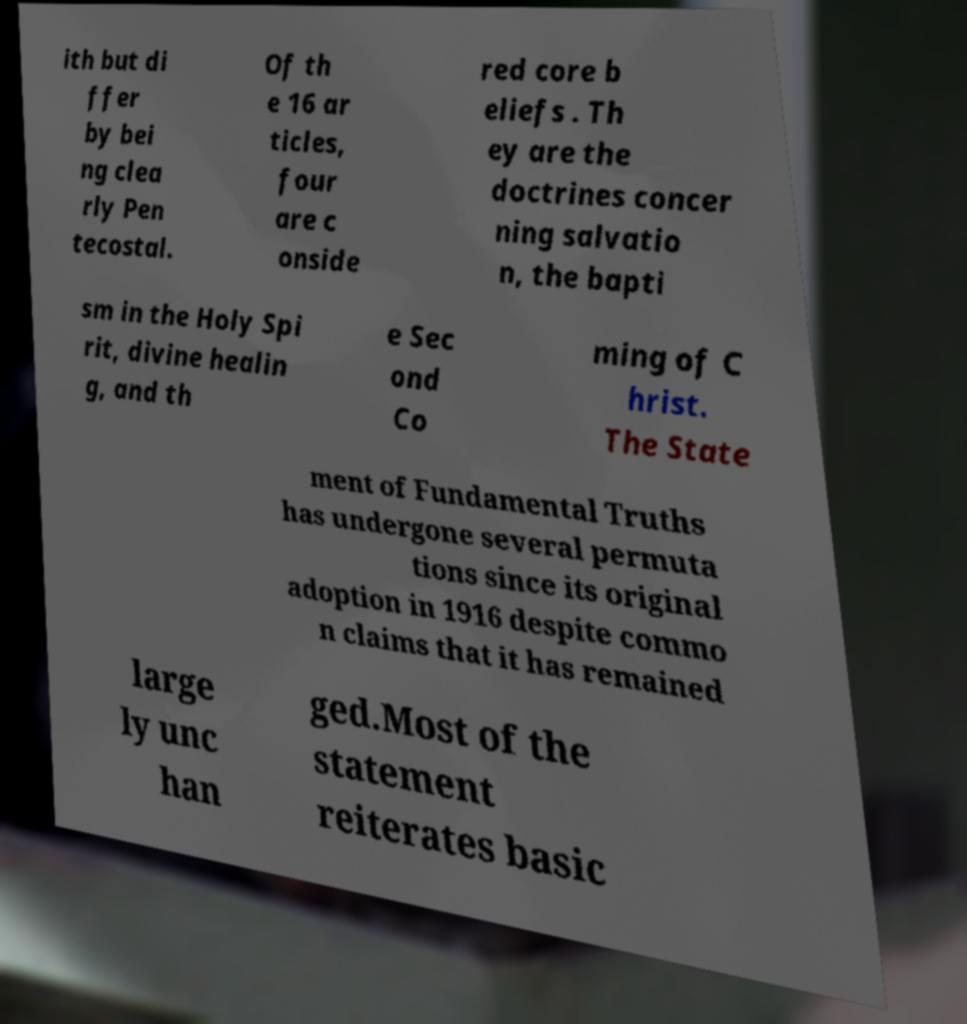I need the written content from this picture converted into text. Can you do that? ith but di ffer by bei ng clea rly Pen tecostal. Of th e 16 ar ticles, four are c onside red core b eliefs . Th ey are the doctrines concer ning salvatio n, the bapti sm in the Holy Spi rit, divine healin g, and th e Sec ond Co ming of C hrist. The State ment of Fundamental Truths has undergone several permuta tions since its original adoption in 1916 despite commo n claims that it has remained large ly unc han ged.Most of the statement reiterates basic 